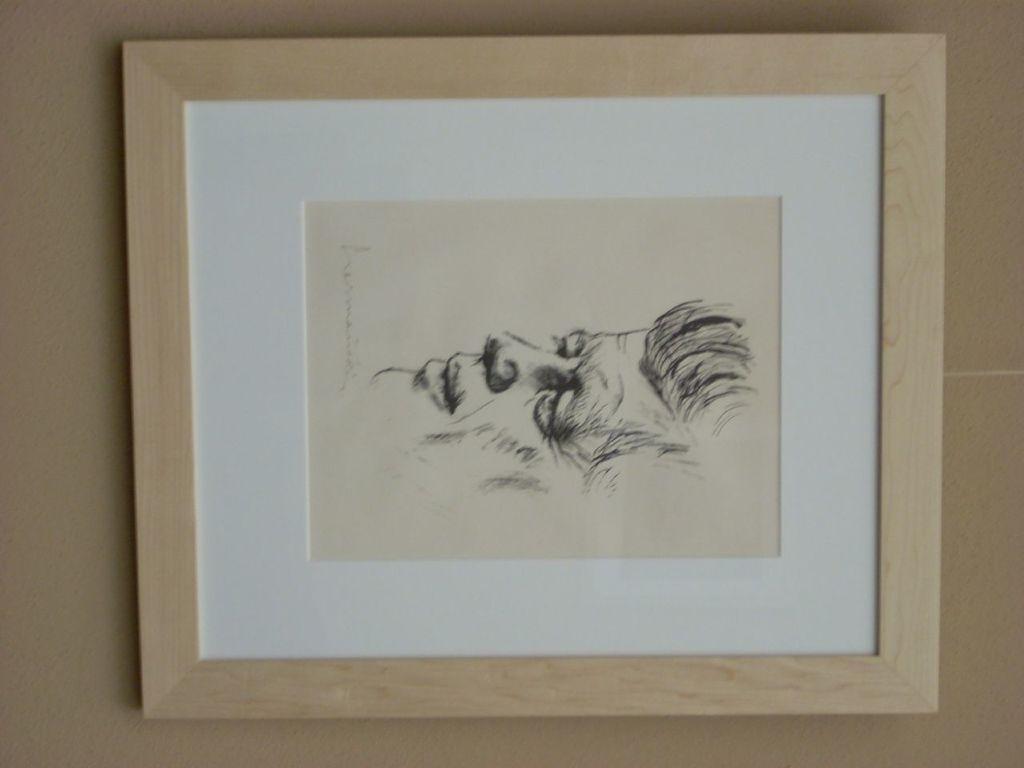In one or two sentences, can you explain what this image depicts? In this image there is a frame on the wall and there is the painting in the frame. 